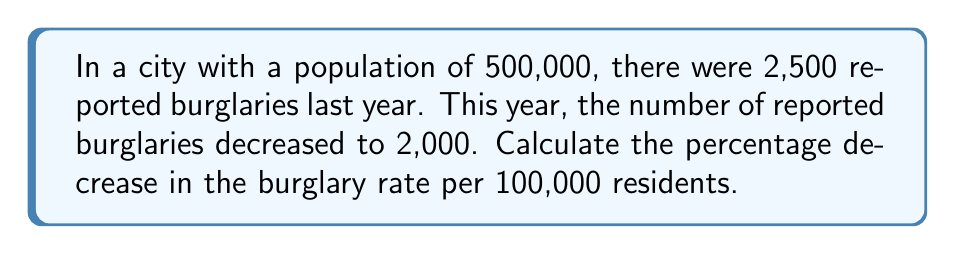Help me with this question. To solve this problem, we'll follow these steps:

1. Calculate the burglary rate per 100,000 residents for last year:
   $$\text{Last year's rate} = \frac{\text{Number of burglaries}}{\text{Total population}} \times 100,000$$
   $$\text{Last year's rate} = \frac{2,500}{500,000} \times 100,000 = 500 \text{ per 100,000}$$

2. Calculate the burglary rate per 100,000 residents for this year:
   $$\text{This year's rate} = \frac{\text{Number of burglaries}}{\text{Total population}} \times 100,000$$
   $$\text{This year's rate} = \frac{2,000}{500,000} \times 100,000 = 400 \text{ per 100,000}$$

3. Calculate the decrease in rate:
   $$\text{Decrease} = \text{Last year's rate} - \text{This year's rate}$$
   $$\text{Decrease} = 500 - 400 = 100 \text{ per 100,000}$$

4. Calculate the percentage decrease:
   $$\text{Percentage decrease} = \frac{\text{Decrease}}{\text{Last year's rate}} \times 100\%$$
   $$\text{Percentage decrease} = \frac{100}{500} \times 100\% = 20\%$$

Therefore, the percentage decrease in the burglary rate per 100,000 residents is 20%.
Answer: 20% 